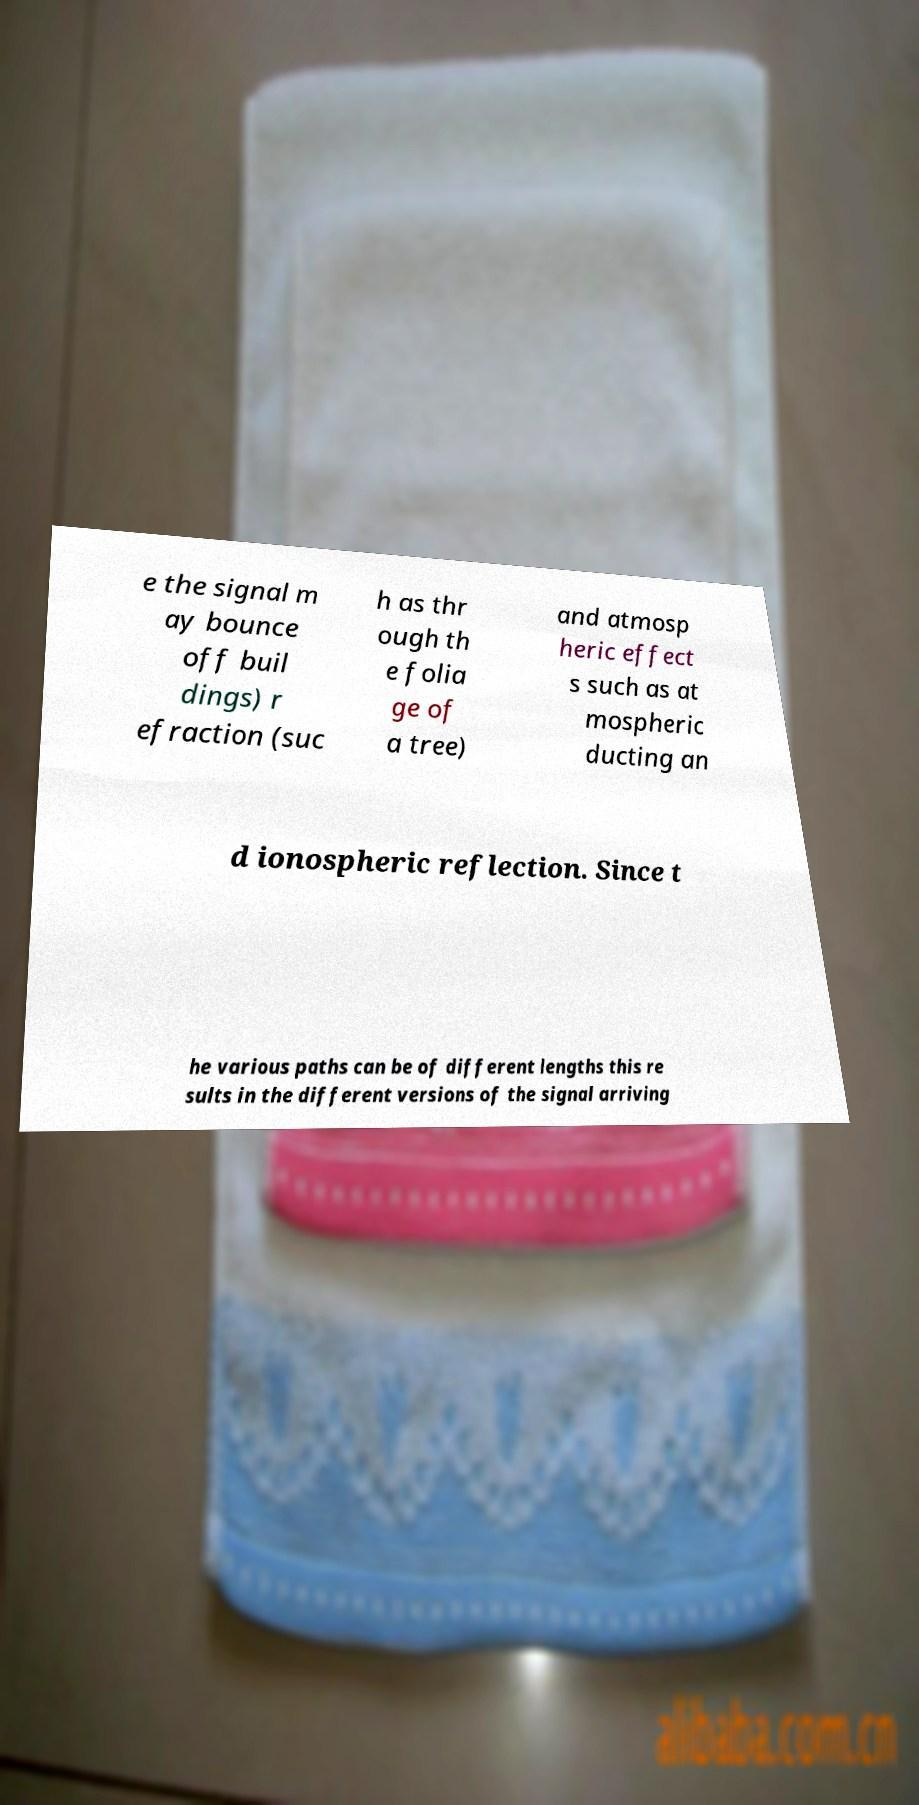There's text embedded in this image that I need extracted. Can you transcribe it verbatim? e the signal m ay bounce off buil dings) r efraction (suc h as thr ough th e folia ge of a tree) and atmosp heric effect s such as at mospheric ducting an d ionospheric reflection. Since t he various paths can be of different lengths this re sults in the different versions of the signal arriving 